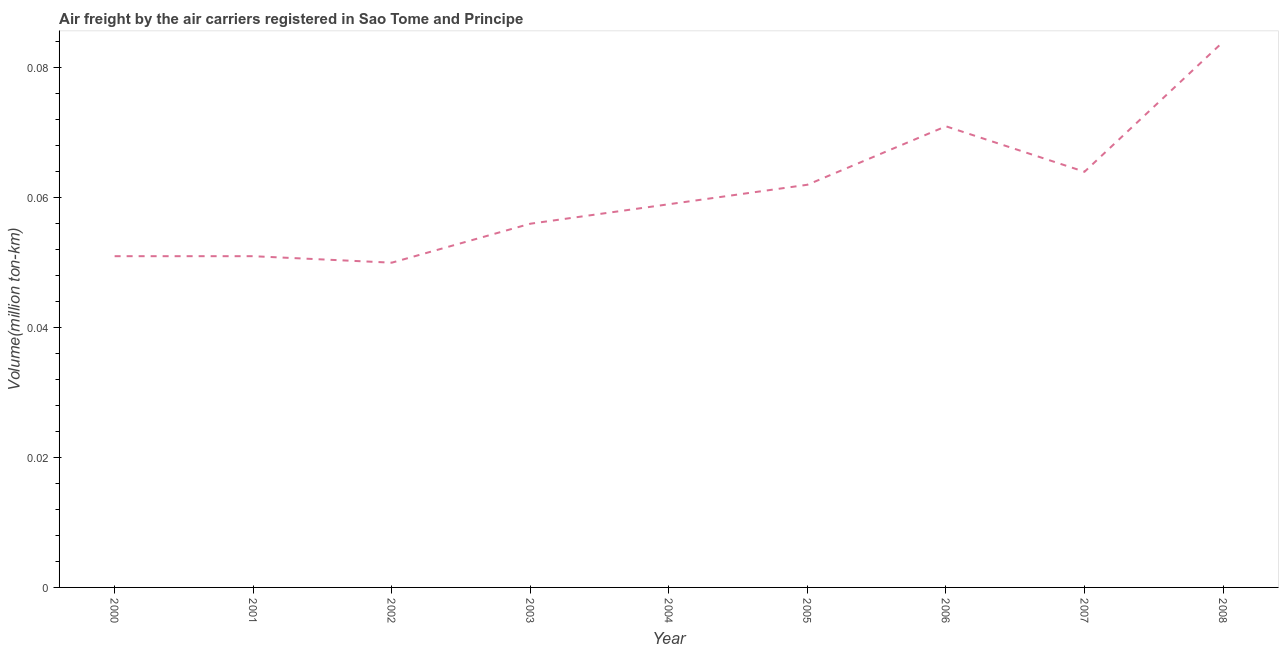What is the air freight in 2006?
Keep it short and to the point. 0.07. Across all years, what is the maximum air freight?
Offer a very short reply. 0.08. Across all years, what is the minimum air freight?
Your answer should be compact. 0.05. In which year was the air freight minimum?
Your response must be concise. 2002. What is the sum of the air freight?
Give a very brief answer. 0.55. What is the difference between the air freight in 2006 and 2007?
Offer a very short reply. 0.01. What is the average air freight per year?
Ensure brevity in your answer.  0.06. What is the median air freight?
Provide a short and direct response. 0.06. In how many years, is the air freight greater than 0.016 million ton-km?
Keep it short and to the point. 9. Do a majority of the years between 2006 and 2004 (inclusive) have air freight greater than 0.068 million ton-km?
Make the answer very short. No. What is the ratio of the air freight in 2005 to that in 2008?
Offer a very short reply. 0.74. Is the air freight in 2002 less than that in 2003?
Keep it short and to the point. Yes. Is the difference between the air freight in 2001 and 2008 greater than the difference between any two years?
Your answer should be compact. No. What is the difference between the highest and the second highest air freight?
Your answer should be very brief. 0.01. What is the difference between the highest and the lowest air freight?
Your answer should be compact. 0.03. Does the air freight monotonically increase over the years?
Offer a very short reply. No. What is the difference between two consecutive major ticks on the Y-axis?
Offer a terse response. 0.02. Does the graph contain any zero values?
Offer a very short reply. No. What is the title of the graph?
Make the answer very short. Air freight by the air carriers registered in Sao Tome and Principe. What is the label or title of the X-axis?
Offer a terse response. Year. What is the label or title of the Y-axis?
Your answer should be compact. Volume(million ton-km). What is the Volume(million ton-km) in 2000?
Your answer should be compact. 0.05. What is the Volume(million ton-km) of 2001?
Your response must be concise. 0.05. What is the Volume(million ton-km) of 2003?
Your answer should be compact. 0.06. What is the Volume(million ton-km) in 2004?
Keep it short and to the point. 0.06. What is the Volume(million ton-km) in 2005?
Your answer should be very brief. 0.06. What is the Volume(million ton-km) in 2006?
Provide a short and direct response. 0.07. What is the Volume(million ton-km) in 2007?
Ensure brevity in your answer.  0.06. What is the Volume(million ton-km) in 2008?
Provide a succinct answer. 0.08. What is the difference between the Volume(million ton-km) in 2000 and 2001?
Ensure brevity in your answer.  0. What is the difference between the Volume(million ton-km) in 2000 and 2002?
Provide a short and direct response. 0. What is the difference between the Volume(million ton-km) in 2000 and 2003?
Provide a succinct answer. -0.01. What is the difference between the Volume(million ton-km) in 2000 and 2004?
Your answer should be very brief. -0.01. What is the difference between the Volume(million ton-km) in 2000 and 2005?
Give a very brief answer. -0.01. What is the difference between the Volume(million ton-km) in 2000 and 2006?
Give a very brief answer. -0.02. What is the difference between the Volume(million ton-km) in 2000 and 2007?
Keep it short and to the point. -0.01. What is the difference between the Volume(million ton-km) in 2000 and 2008?
Offer a terse response. -0.03. What is the difference between the Volume(million ton-km) in 2001 and 2003?
Offer a terse response. -0.01. What is the difference between the Volume(million ton-km) in 2001 and 2004?
Your answer should be compact. -0.01. What is the difference between the Volume(million ton-km) in 2001 and 2005?
Offer a terse response. -0.01. What is the difference between the Volume(million ton-km) in 2001 and 2006?
Offer a terse response. -0.02. What is the difference between the Volume(million ton-km) in 2001 and 2007?
Your answer should be compact. -0.01. What is the difference between the Volume(million ton-km) in 2001 and 2008?
Offer a terse response. -0.03. What is the difference between the Volume(million ton-km) in 2002 and 2003?
Keep it short and to the point. -0.01. What is the difference between the Volume(million ton-km) in 2002 and 2004?
Offer a terse response. -0.01. What is the difference between the Volume(million ton-km) in 2002 and 2005?
Make the answer very short. -0.01. What is the difference between the Volume(million ton-km) in 2002 and 2006?
Your answer should be compact. -0.02. What is the difference between the Volume(million ton-km) in 2002 and 2007?
Give a very brief answer. -0.01. What is the difference between the Volume(million ton-km) in 2002 and 2008?
Keep it short and to the point. -0.03. What is the difference between the Volume(million ton-km) in 2003 and 2004?
Your answer should be compact. -0. What is the difference between the Volume(million ton-km) in 2003 and 2005?
Your response must be concise. -0.01. What is the difference between the Volume(million ton-km) in 2003 and 2006?
Keep it short and to the point. -0.01. What is the difference between the Volume(million ton-km) in 2003 and 2007?
Ensure brevity in your answer.  -0.01. What is the difference between the Volume(million ton-km) in 2003 and 2008?
Your response must be concise. -0.03. What is the difference between the Volume(million ton-km) in 2004 and 2005?
Provide a short and direct response. -0. What is the difference between the Volume(million ton-km) in 2004 and 2006?
Offer a very short reply. -0.01. What is the difference between the Volume(million ton-km) in 2004 and 2007?
Keep it short and to the point. -0.01. What is the difference between the Volume(million ton-km) in 2004 and 2008?
Keep it short and to the point. -0.03. What is the difference between the Volume(million ton-km) in 2005 and 2006?
Offer a terse response. -0.01. What is the difference between the Volume(million ton-km) in 2005 and 2007?
Provide a short and direct response. -0. What is the difference between the Volume(million ton-km) in 2005 and 2008?
Offer a very short reply. -0.02. What is the difference between the Volume(million ton-km) in 2006 and 2007?
Provide a short and direct response. 0.01. What is the difference between the Volume(million ton-km) in 2006 and 2008?
Your answer should be very brief. -0.01. What is the difference between the Volume(million ton-km) in 2007 and 2008?
Provide a short and direct response. -0.02. What is the ratio of the Volume(million ton-km) in 2000 to that in 2001?
Your response must be concise. 1. What is the ratio of the Volume(million ton-km) in 2000 to that in 2003?
Offer a very short reply. 0.91. What is the ratio of the Volume(million ton-km) in 2000 to that in 2004?
Keep it short and to the point. 0.86. What is the ratio of the Volume(million ton-km) in 2000 to that in 2005?
Provide a short and direct response. 0.82. What is the ratio of the Volume(million ton-km) in 2000 to that in 2006?
Your answer should be compact. 0.72. What is the ratio of the Volume(million ton-km) in 2000 to that in 2007?
Make the answer very short. 0.8. What is the ratio of the Volume(million ton-km) in 2000 to that in 2008?
Provide a succinct answer. 0.61. What is the ratio of the Volume(million ton-km) in 2001 to that in 2002?
Make the answer very short. 1.02. What is the ratio of the Volume(million ton-km) in 2001 to that in 2003?
Your answer should be compact. 0.91. What is the ratio of the Volume(million ton-km) in 2001 to that in 2004?
Give a very brief answer. 0.86. What is the ratio of the Volume(million ton-km) in 2001 to that in 2005?
Give a very brief answer. 0.82. What is the ratio of the Volume(million ton-km) in 2001 to that in 2006?
Offer a terse response. 0.72. What is the ratio of the Volume(million ton-km) in 2001 to that in 2007?
Provide a short and direct response. 0.8. What is the ratio of the Volume(million ton-km) in 2001 to that in 2008?
Keep it short and to the point. 0.61. What is the ratio of the Volume(million ton-km) in 2002 to that in 2003?
Provide a short and direct response. 0.89. What is the ratio of the Volume(million ton-km) in 2002 to that in 2004?
Keep it short and to the point. 0.85. What is the ratio of the Volume(million ton-km) in 2002 to that in 2005?
Your response must be concise. 0.81. What is the ratio of the Volume(million ton-km) in 2002 to that in 2006?
Your response must be concise. 0.7. What is the ratio of the Volume(million ton-km) in 2002 to that in 2007?
Your answer should be very brief. 0.78. What is the ratio of the Volume(million ton-km) in 2002 to that in 2008?
Make the answer very short. 0.59. What is the ratio of the Volume(million ton-km) in 2003 to that in 2004?
Provide a short and direct response. 0.95. What is the ratio of the Volume(million ton-km) in 2003 to that in 2005?
Your answer should be compact. 0.9. What is the ratio of the Volume(million ton-km) in 2003 to that in 2006?
Provide a succinct answer. 0.79. What is the ratio of the Volume(million ton-km) in 2003 to that in 2008?
Provide a succinct answer. 0.67. What is the ratio of the Volume(million ton-km) in 2004 to that in 2006?
Your response must be concise. 0.83. What is the ratio of the Volume(million ton-km) in 2004 to that in 2007?
Offer a very short reply. 0.92. What is the ratio of the Volume(million ton-km) in 2004 to that in 2008?
Ensure brevity in your answer.  0.7. What is the ratio of the Volume(million ton-km) in 2005 to that in 2006?
Provide a succinct answer. 0.87. What is the ratio of the Volume(million ton-km) in 2005 to that in 2008?
Provide a succinct answer. 0.74. What is the ratio of the Volume(million ton-km) in 2006 to that in 2007?
Your answer should be very brief. 1.11. What is the ratio of the Volume(million ton-km) in 2006 to that in 2008?
Offer a terse response. 0.84. What is the ratio of the Volume(million ton-km) in 2007 to that in 2008?
Offer a terse response. 0.76. 